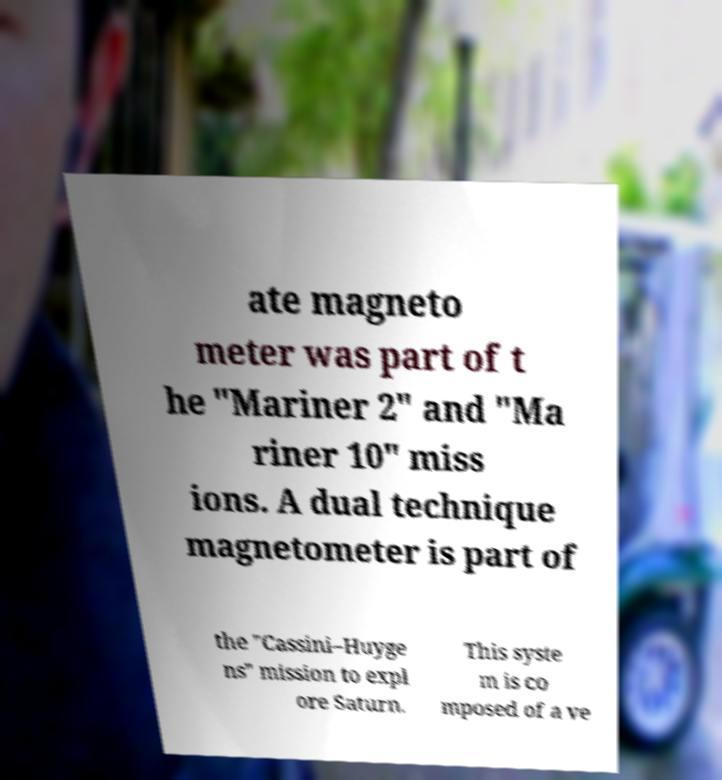Please read and relay the text visible in this image. What does it say? ate magneto meter was part of t he "Mariner 2" and "Ma riner 10" miss ions. A dual technique magnetometer is part of the "Cassini–Huyge ns" mission to expl ore Saturn. This syste m is co mposed of a ve 